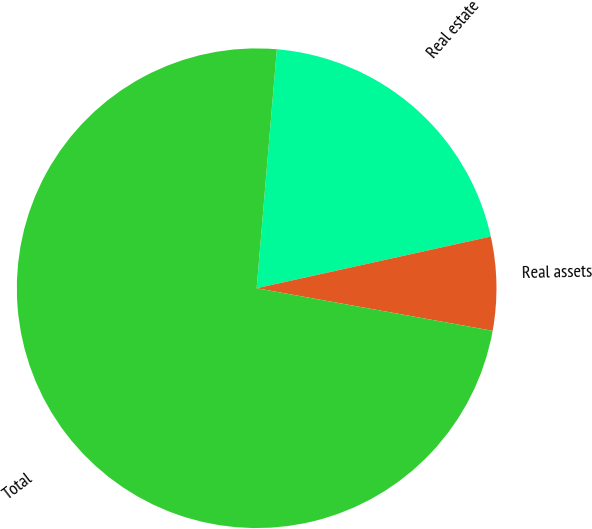Convert chart. <chart><loc_0><loc_0><loc_500><loc_500><pie_chart><fcel>Real estate<fcel>Real assets<fcel>Total<nl><fcel>20.2%<fcel>6.3%<fcel>73.5%<nl></chart> 